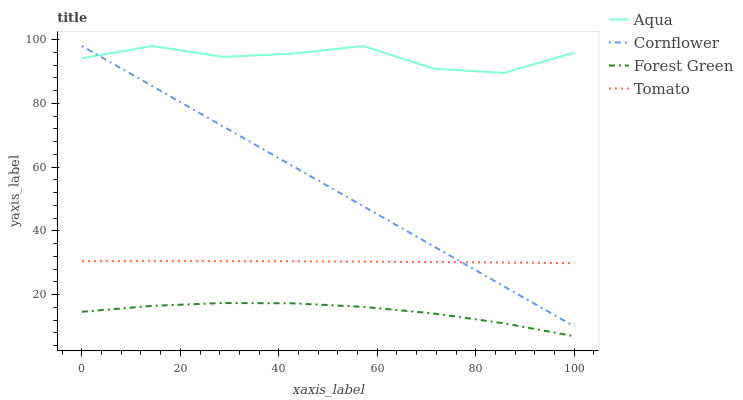Does Forest Green have the minimum area under the curve?
Answer yes or no. Yes. Does Aqua have the maximum area under the curve?
Answer yes or no. Yes. Does Cornflower have the minimum area under the curve?
Answer yes or no. No. Does Cornflower have the maximum area under the curve?
Answer yes or no. No. Is Cornflower the smoothest?
Answer yes or no. Yes. Is Aqua the roughest?
Answer yes or no. Yes. Is Forest Green the smoothest?
Answer yes or no. No. Is Forest Green the roughest?
Answer yes or no. No. Does Forest Green have the lowest value?
Answer yes or no. Yes. Does Cornflower have the lowest value?
Answer yes or no. No. Does Aqua have the highest value?
Answer yes or no. Yes. Does Forest Green have the highest value?
Answer yes or no. No. Is Tomato less than Aqua?
Answer yes or no. Yes. Is Aqua greater than Tomato?
Answer yes or no. Yes. Does Cornflower intersect Aqua?
Answer yes or no. Yes. Is Cornflower less than Aqua?
Answer yes or no. No. Is Cornflower greater than Aqua?
Answer yes or no. No. Does Tomato intersect Aqua?
Answer yes or no. No. 